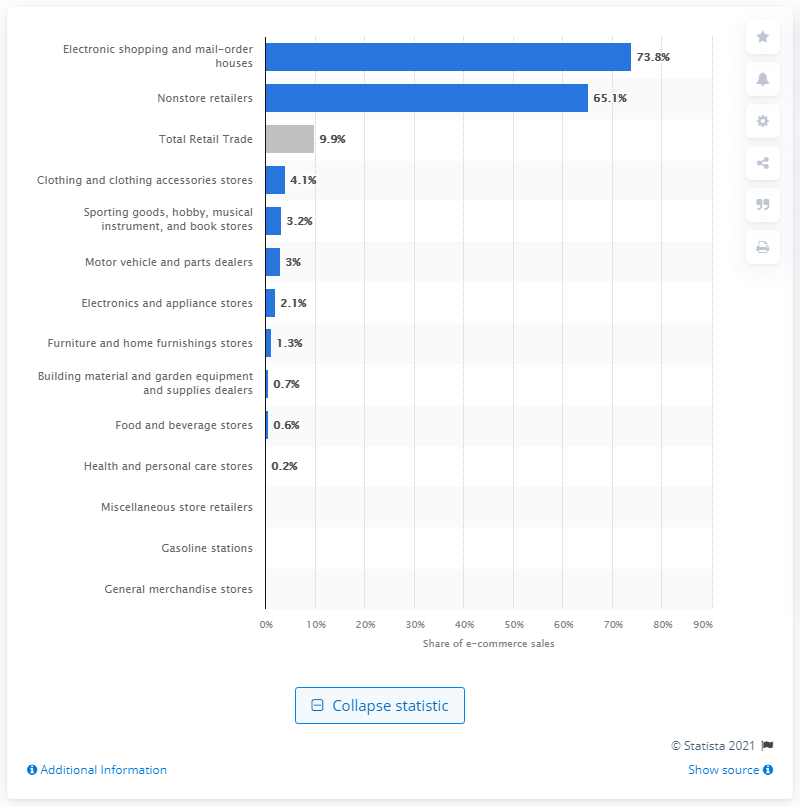Mention a couple of crucial points in this snapshot. In 2018, e-commerce accounted for approximately 10% of total U.S. retail sales. According to a recent U.S. Census Bureau report, e-commerce sales accounted for 9.9% of total retail sales in the United States in 2018. In 2018, e-commerce accounted for 4.1% of the total sales of clothing and clothing accessories in the retail trade industry. 